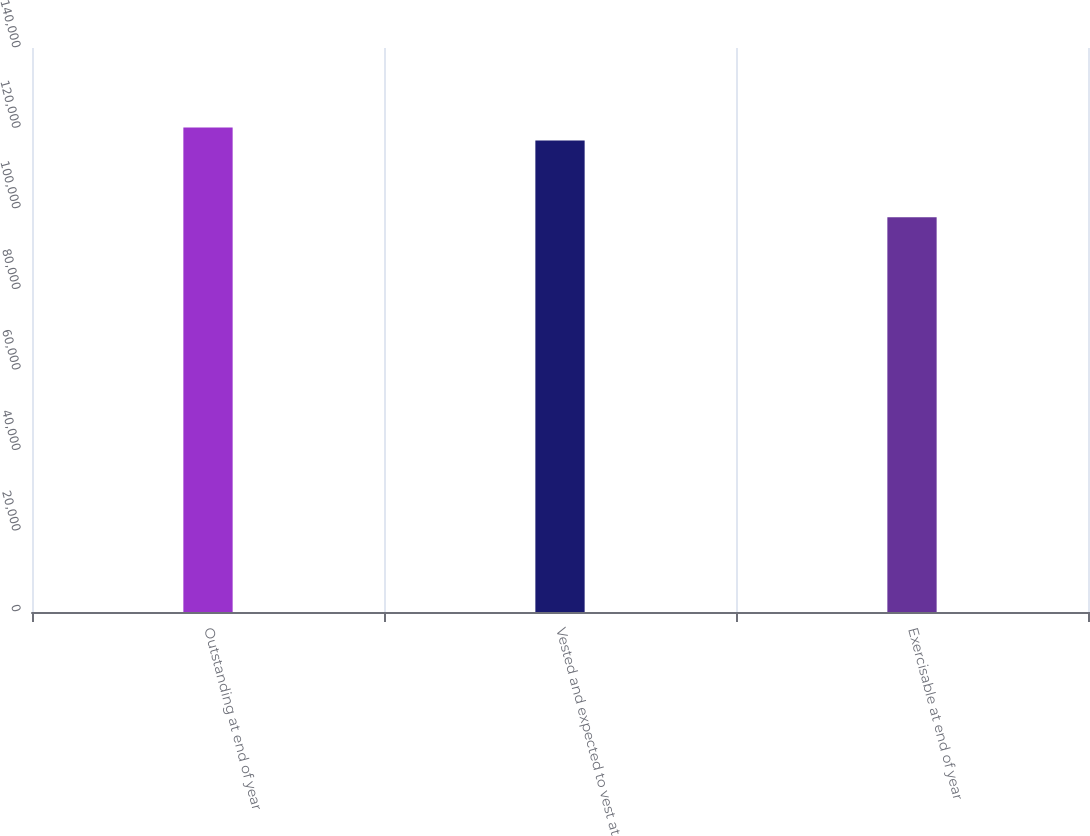<chart> <loc_0><loc_0><loc_500><loc_500><bar_chart><fcel>Outstanding at end of year<fcel>Vested and expected to vest at<fcel>Exercisable at end of year<nl><fcel>120243<fcel>117066<fcel>97967<nl></chart> 